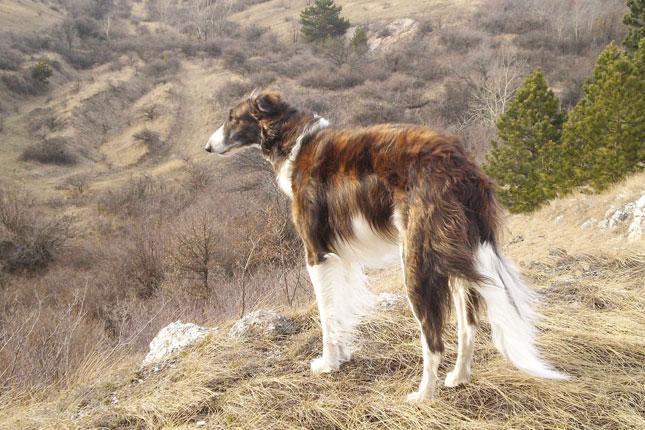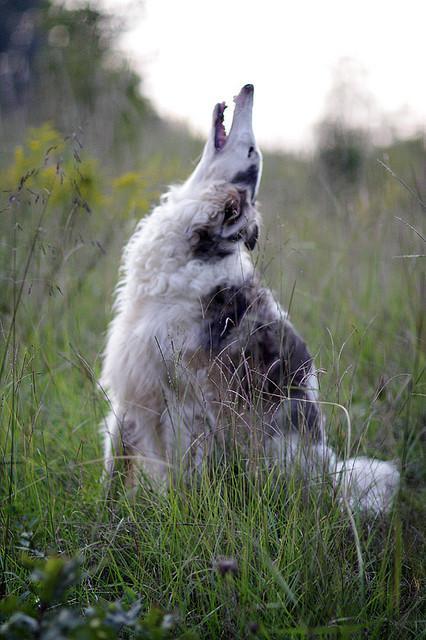The first image is the image on the left, the second image is the image on the right. Given the left and right images, does the statement "There are two dogs" hold true? Answer yes or no. Yes. 